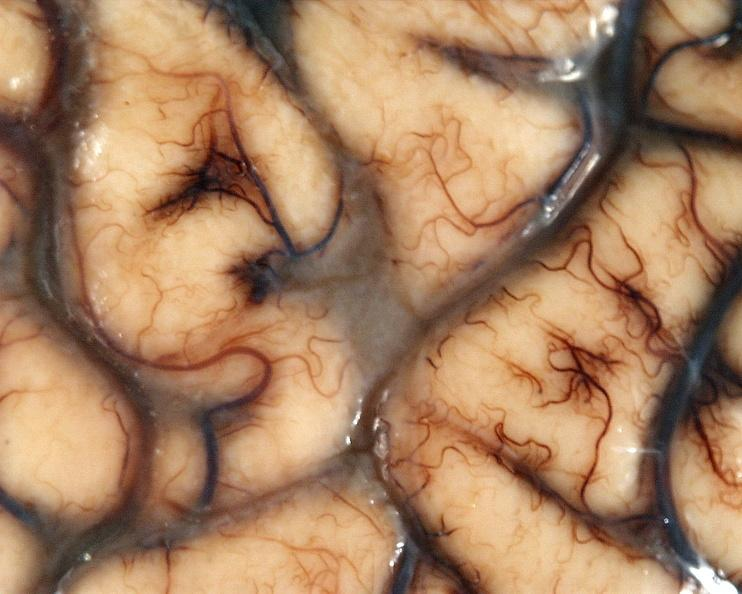s there present?
Answer the question using a single word or phrase. No 